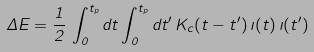Convert formula to latex. <formula><loc_0><loc_0><loc_500><loc_500>\Delta E = \frac { 1 } { 2 } \, \int _ { 0 } ^ { t _ { p } } d t \int _ { 0 } ^ { t _ { p } } d t ^ { \prime } \, K _ { c } ( t - t ^ { \prime } ) \, \zeta ( t ) \, \zeta ( t ^ { \prime } )</formula> 